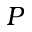<formula> <loc_0><loc_0><loc_500><loc_500>P</formula> 